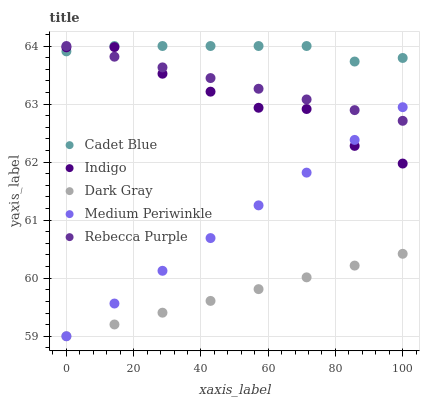Does Dark Gray have the minimum area under the curve?
Answer yes or no. Yes. Does Cadet Blue have the maximum area under the curve?
Answer yes or no. Yes. Does Medium Periwinkle have the minimum area under the curve?
Answer yes or no. No. Does Medium Periwinkle have the maximum area under the curve?
Answer yes or no. No. Is Rebecca Purple the smoothest?
Answer yes or no. Yes. Is Indigo the roughest?
Answer yes or no. Yes. Is Medium Periwinkle the smoothest?
Answer yes or no. No. Is Medium Periwinkle the roughest?
Answer yes or no. No. Does Dark Gray have the lowest value?
Answer yes or no. Yes. Does Cadet Blue have the lowest value?
Answer yes or no. No. Does Rebecca Purple have the highest value?
Answer yes or no. Yes. Does Medium Periwinkle have the highest value?
Answer yes or no. No. Is Dark Gray less than Rebecca Purple?
Answer yes or no. Yes. Is Indigo greater than Dark Gray?
Answer yes or no. Yes. Does Rebecca Purple intersect Indigo?
Answer yes or no. Yes. Is Rebecca Purple less than Indigo?
Answer yes or no. No. Is Rebecca Purple greater than Indigo?
Answer yes or no. No. Does Dark Gray intersect Rebecca Purple?
Answer yes or no. No. 